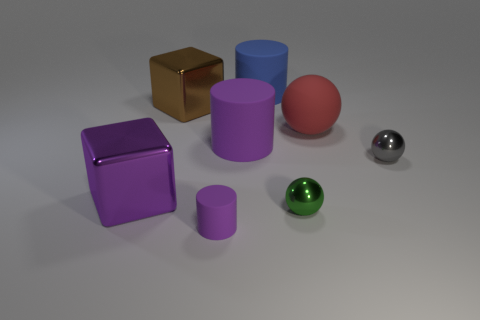How many other things are the same color as the small matte cylinder?
Your answer should be compact. 2. Are there any purple cylinders behind the small green metal sphere?
Your response must be concise. Yes. What is the color of the big cube that is on the left side of the large cube that is behind the big purple object in front of the small gray ball?
Offer a terse response. Purple. What number of things are both in front of the small green shiny sphere and behind the brown metal object?
Provide a succinct answer. 0. What number of spheres are red metallic objects or blue matte things?
Your answer should be compact. 0. Is there a large rubber object?
Your answer should be very brief. Yes. What number of other things are made of the same material as the tiny cylinder?
Offer a very short reply. 3. What is the material of the ball that is the same size as the green shiny object?
Offer a very short reply. Metal. Is the shape of the large rubber object right of the blue rubber object the same as  the big brown object?
Provide a short and direct response. No. What number of objects are big things in front of the red ball or large things?
Your answer should be very brief. 5. 